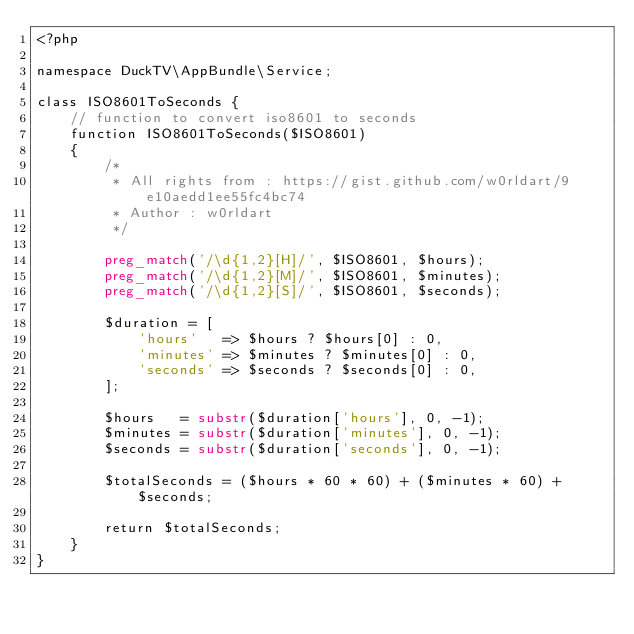Convert code to text. <code><loc_0><loc_0><loc_500><loc_500><_PHP_><?php

namespace DuckTV\AppBundle\Service;

class ISO8601ToSeconds {
    // function to convert iso8601 to seconds
    function ISO8601ToSeconds($ISO8601)
    {
        /*
         * All rights from : https://gist.github.com/w0rldart/9e10aedd1ee55fc4bc74
         * Author : w0rldart
         */

        preg_match('/\d{1,2}[H]/', $ISO8601, $hours);
        preg_match('/\d{1,2}[M]/', $ISO8601, $minutes);
        preg_match('/\d{1,2}[S]/', $ISO8601, $seconds);

        $duration = [
            'hours'   => $hours ? $hours[0] : 0,
            'minutes' => $minutes ? $minutes[0] : 0,
            'seconds' => $seconds ? $seconds[0] : 0,
        ];

        $hours   = substr($duration['hours'], 0, -1);
        $minutes = substr($duration['minutes'], 0, -1);
        $seconds = substr($duration['seconds'], 0, -1);

        $totalSeconds = ($hours * 60 * 60) + ($minutes * 60) + $seconds;

        return $totalSeconds;
    }
}</code> 